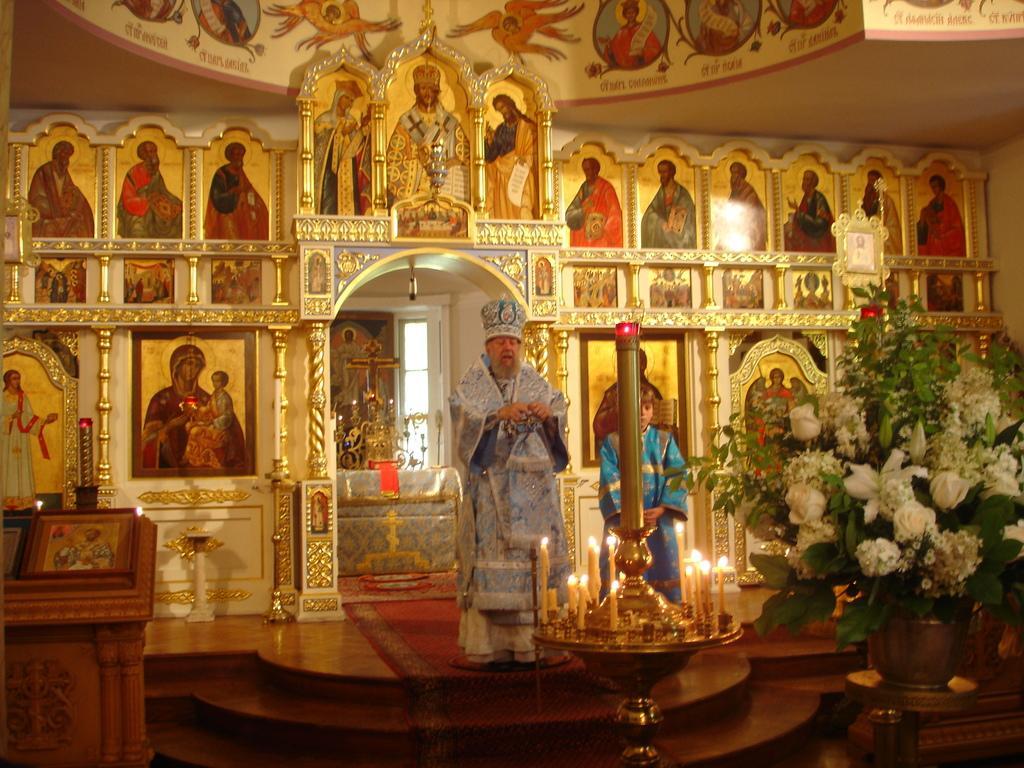Please provide a concise description of this image. In this image there is an inside view of a church, there is a man standing, there is a boy standing, there is a stand towards the bottom of the image, there are candles on the stand, there is a table towards the bottom of the image, there is a flower pot on the table, there is a plant towards the right of the image, there are flowers, there is a podium towards the left of the image, there are photo frames on the podium, there is the wall, there is a painting on the wall. 